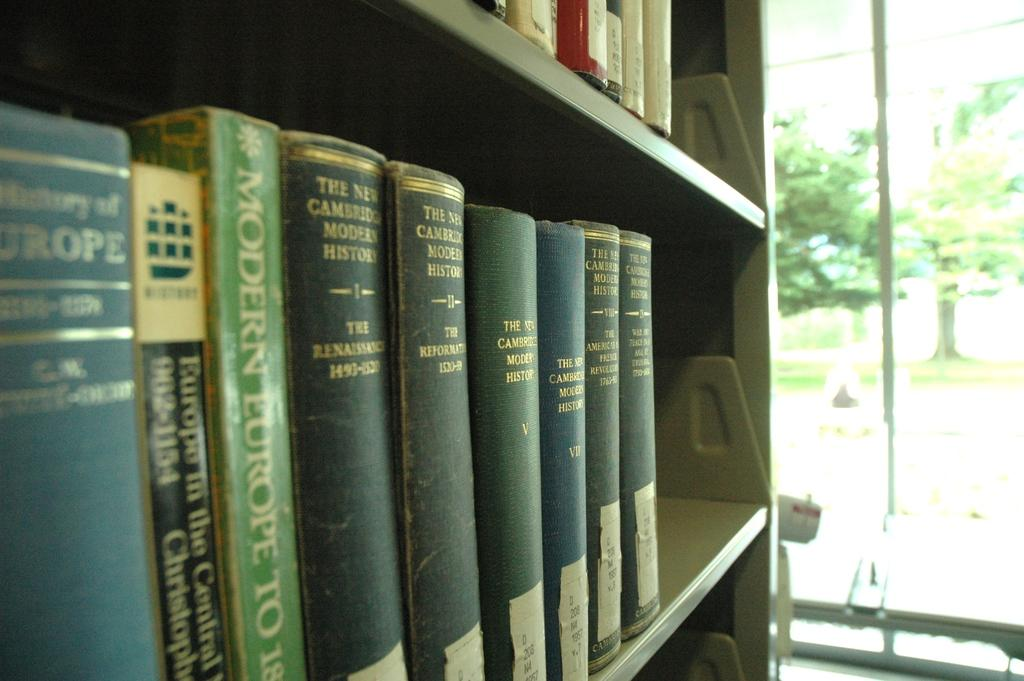<image>
Write a terse but informative summary of the picture. a book that has the word history on it 